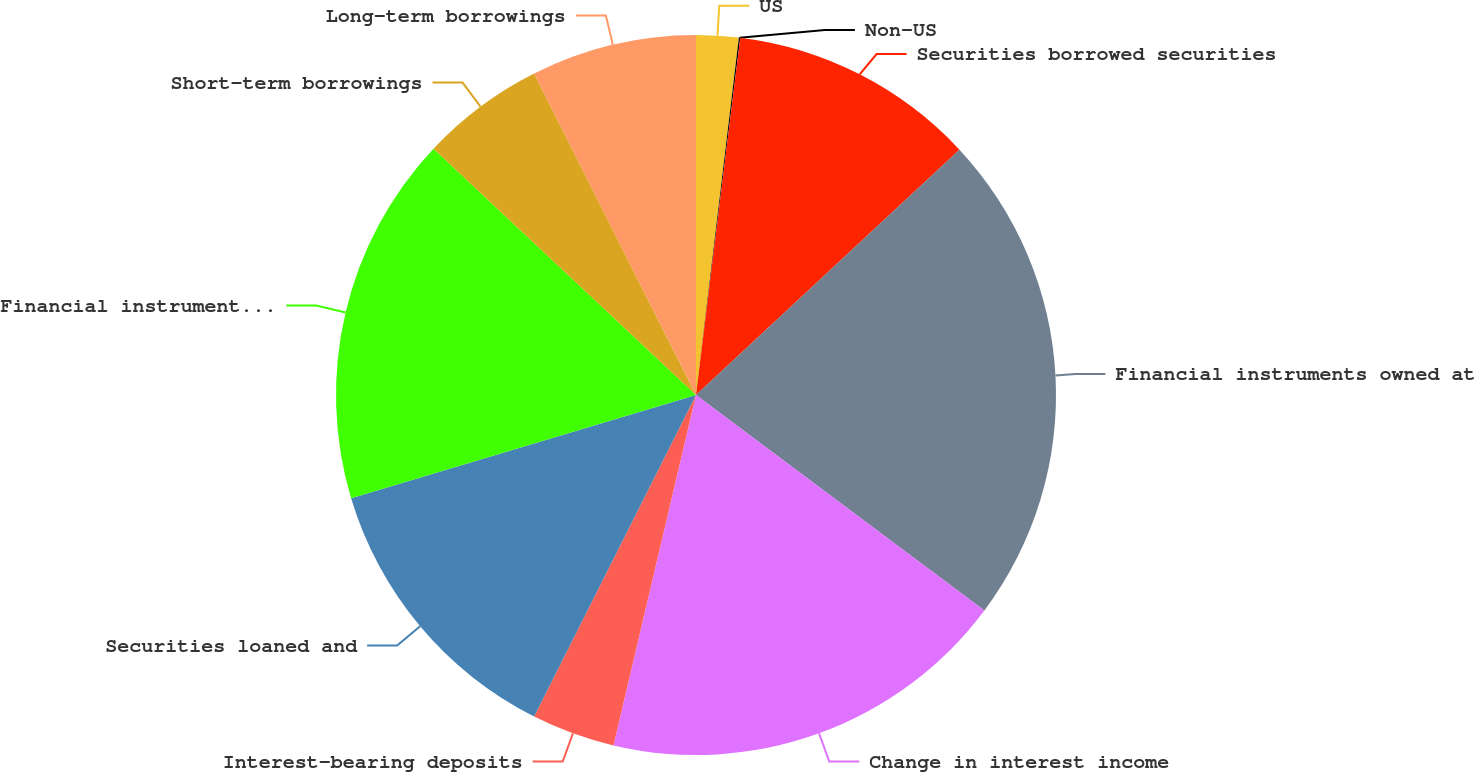<chart> <loc_0><loc_0><loc_500><loc_500><pie_chart><fcel>US<fcel>Non-US<fcel>Securities borrowed securities<fcel>Financial instruments owned at<fcel>Change in interest income<fcel>Interest-bearing deposits<fcel>Securities loaned and<fcel>Financial instruments sold but<fcel>Short-term borrowings<fcel>Long-term borrowings<nl><fcel>1.9%<fcel>0.06%<fcel>11.1%<fcel>22.14%<fcel>18.46%<fcel>3.74%<fcel>12.94%<fcel>16.62%<fcel>5.58%<fcel>7.42%<nl></chart> 